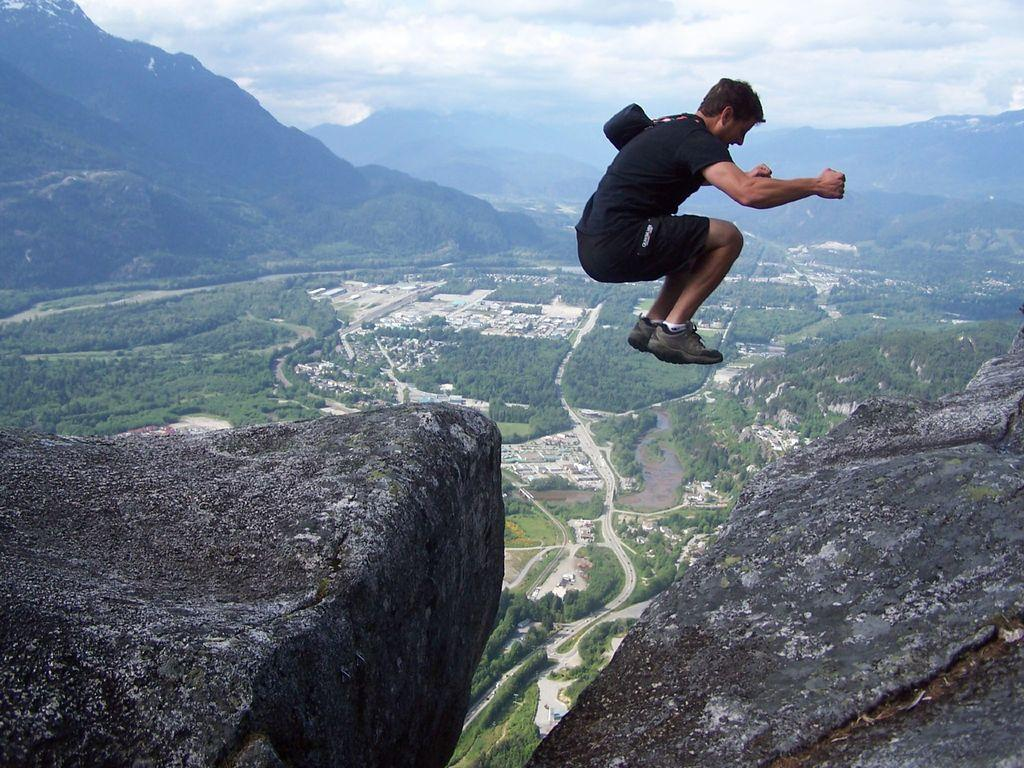Who is the main subject in the image? There is a man in the image. What is the man doing in the image? The man is jumping from a rock in the image. What type of natural environment is depicted in the image? There are trees, roads, hills, and the sky visible in the image. Can you describe the sky in the image? The sky is visible in the image, and clouds are present. How many spiders can be seen crawling on the border of the image? There are no spiders present in the image, and there is no border to observe. What type of yard is visible in the image? There is no yard visible in the image; it depicts a natural environment with trees, roads, hills, and the sky. 